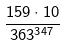Convert formula to latex. <formula><loc_0><loc_0><loc_500><loc_500>\frac { 1 5 9 \cdot 1 0 } { 3 6 3 ^ { 3 4 7 } }</formula> 